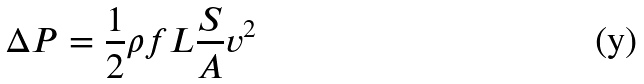Convert formula to latex. <formula><loc_0><loc_0><loc_500><loc_500>\Delta P = \frac { 1 } { 2 } \rho f L \frac { S } { A } v ^ { 2 }</formula> 